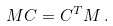<formula> <loc_0><loc_0><loc_500><loc_500>M C = C ^ { T } M \, .</formula> 